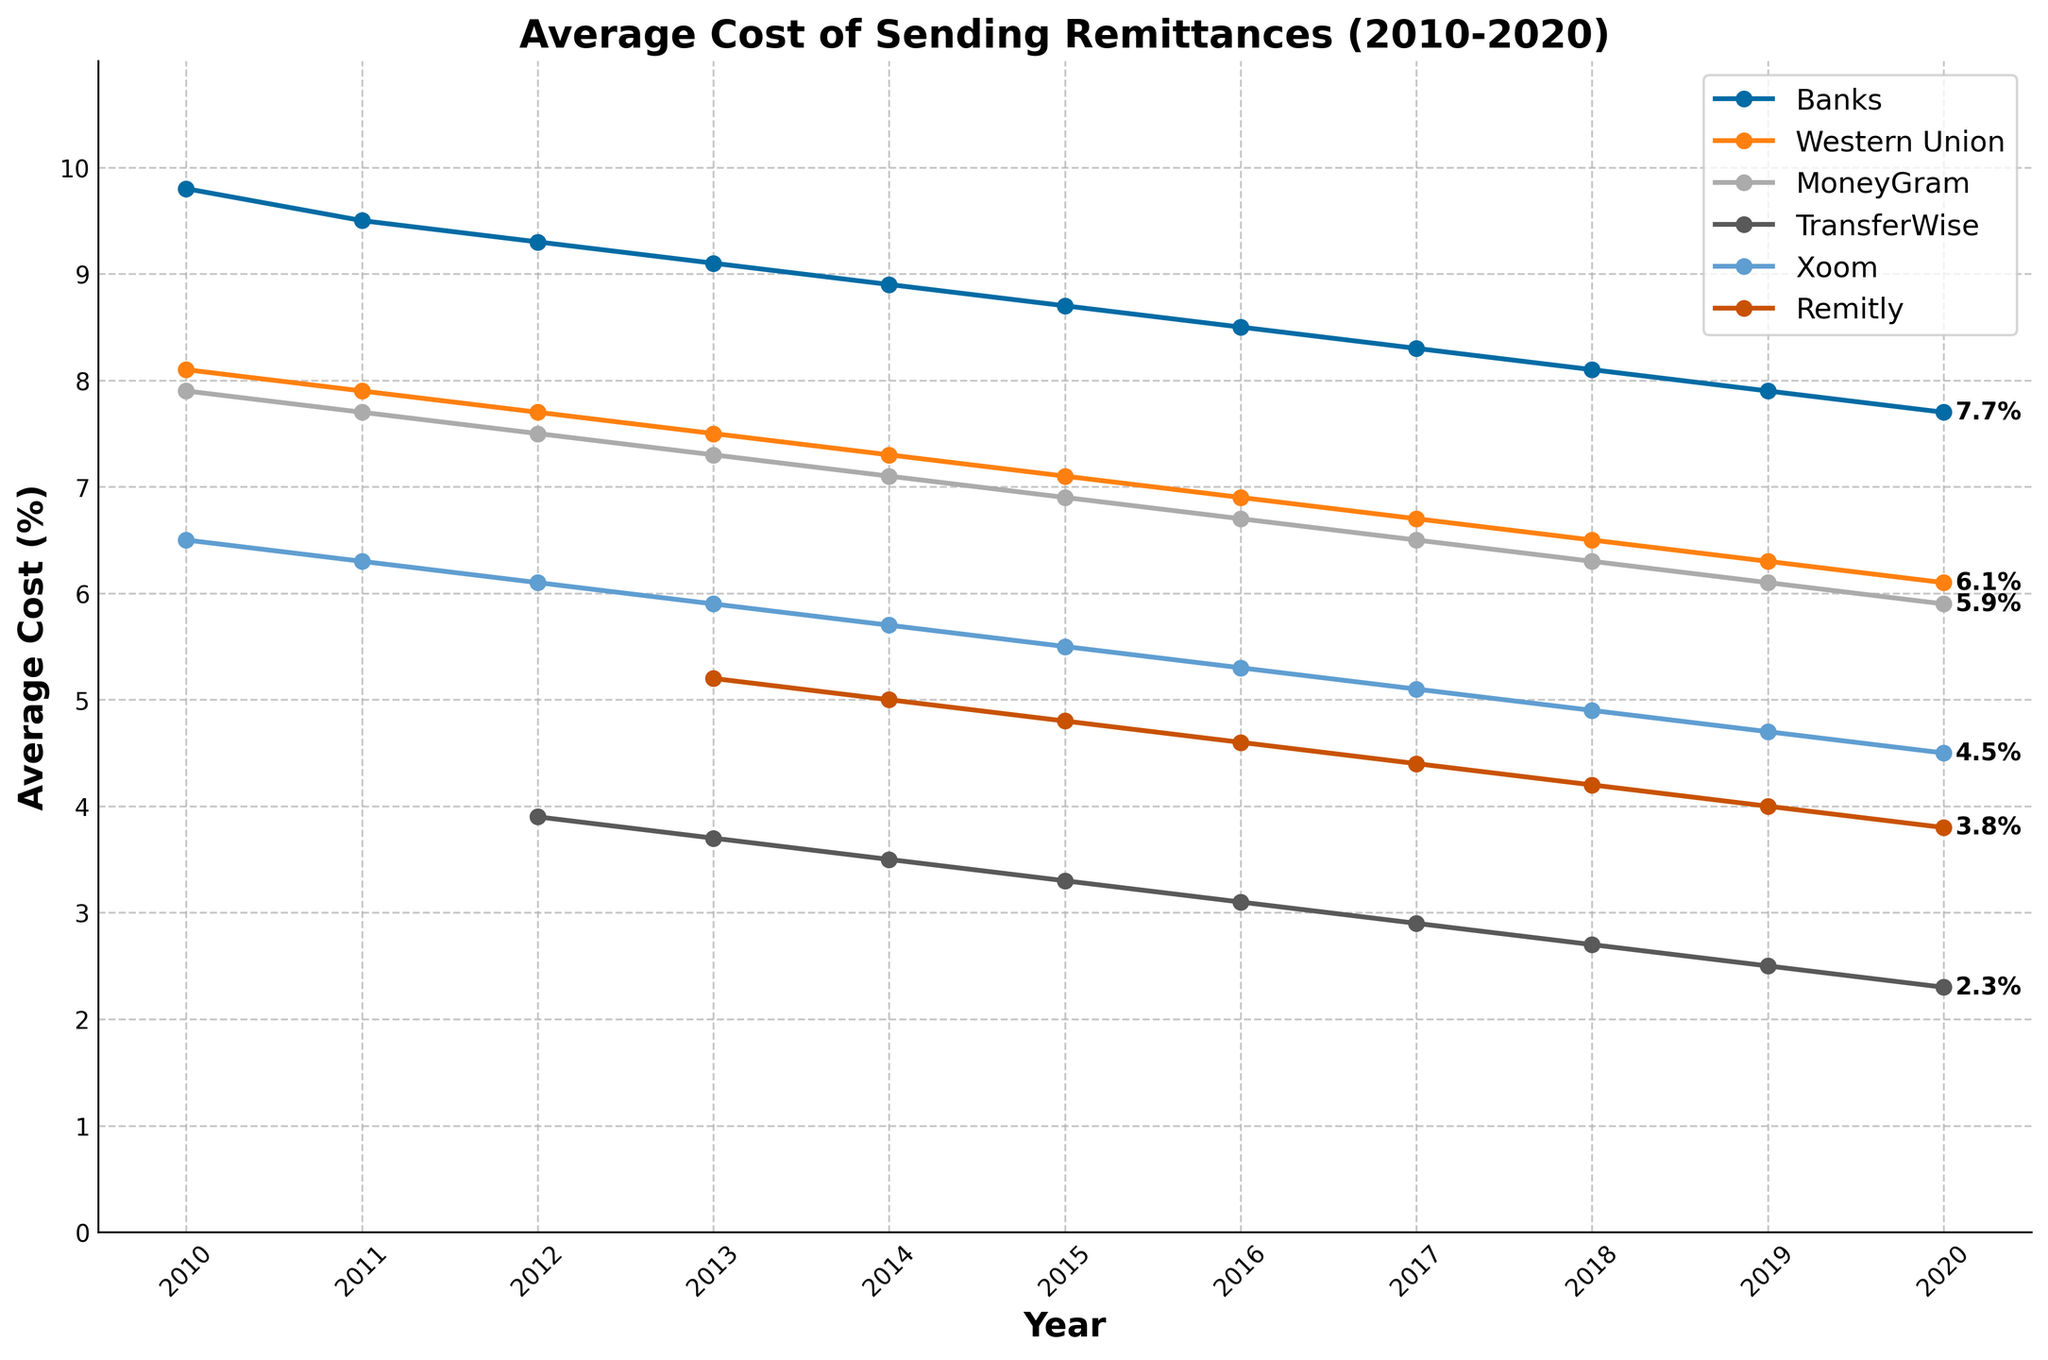What is the trend in the average cost of sending remittances through banks from 2010 to 2020? The average cost through banks shows a consistent downward trend from 9.8% in 2010 to 7.7% in 2020, indicating a gradual decrease over the years.
Answer: Downward trend from 9.8% to 7.7% Which channel had the lowest average cost of sending remittances in 2019? To identify the channel with the lowest cost in 2019, we compare the values for all channels: Banks (7.9%), Western Union (6.3%), MoneyGram (6.1%), TransferWise (2.5%), Xoom (4.7%), Remitly (4.0%). TransferWise has the lowest cost of 2.5%.
Answer: TransferWise How does the average cost of sending remittances through TransferWise in 2020 compare to that of banks in 2020? TransferWise's cost in 2020 is 2.3%, while the banks' cost is 7.7%. Comparatively, TransferWise is significantly cheaper.
Answer: TransferWise is cheaper Calculate the difference between the average cost through Western Union and through Xoom in 2015. Western Union's cost in 2015 is 7.1%, and Xoom's cost is 5.5%. The difference is 7.1% - 5.5% = 1.6%.
Answer: 1.6% Which channel saw the most significant decrease in average cost from 2010 to 2020? To find the most significant decrease, calculate the difference for each channel: Banks (9.8% to 7.7%; 2.1%), Western Union (8.1% to 6.1%; 2.0%), MoneyGram (7.9% to 5.9%; 2.0%), TransferWise (3.9% to 2.3%; 1.6%), Xoom (6.5% to 4.5%; 2.0%), Remitly (5.2% to 3.8%; 1.4%). Banks have the largest decrease of 2.1%.
Answer: Banks Which two channels had an average cost under 5% in 2020? In 2020, the channels with costs under 5% are TransferWise (2.3%), Xoom (4.5%), and Remitly (3.8%).
Answer: TransferWise and Remitly What is the average cost of sending remittances through Remitly over the years it appears in the plot? Remitly's costs are available from 2013 to 2020: (5.2 + 5.0 + 4.8 + 4.6 + 4.4 + 4.2 + 4.0 + 3.8) / 8 = 35 / 8 = 4.375%.
Answer: 4.375% By how much did the average cost of sending remittances through Xoom decrease from 2010 to 2020? Xoom's cost decreased from 6.5% in 2010 to 4.5% in 2020. The reduction is 6.5% - 4.5% = 2.0%.
Answer: 2.0% Which channel had the smallest change in average cost from 2010 to 2020? The smallest change is calculated for each channel and compared: Banks (2.1%), Western Union (2.0%), MoneyGram (2.0%), TransferWise (1.6%), Xoom (2.0%), Remitly (1.4%). Remitly has the smallest change.
Answer: Remitly How does the average cost trend of MoneyGram compare to Western Union from 2010 to 2020? Both Western Union and MoneyGram show a decreasing trend over the years; however, MoneyGram consistently has a slightly lower average cost than Western Union throughout the period.
Answer: Both decrease, MoneyGram lower 